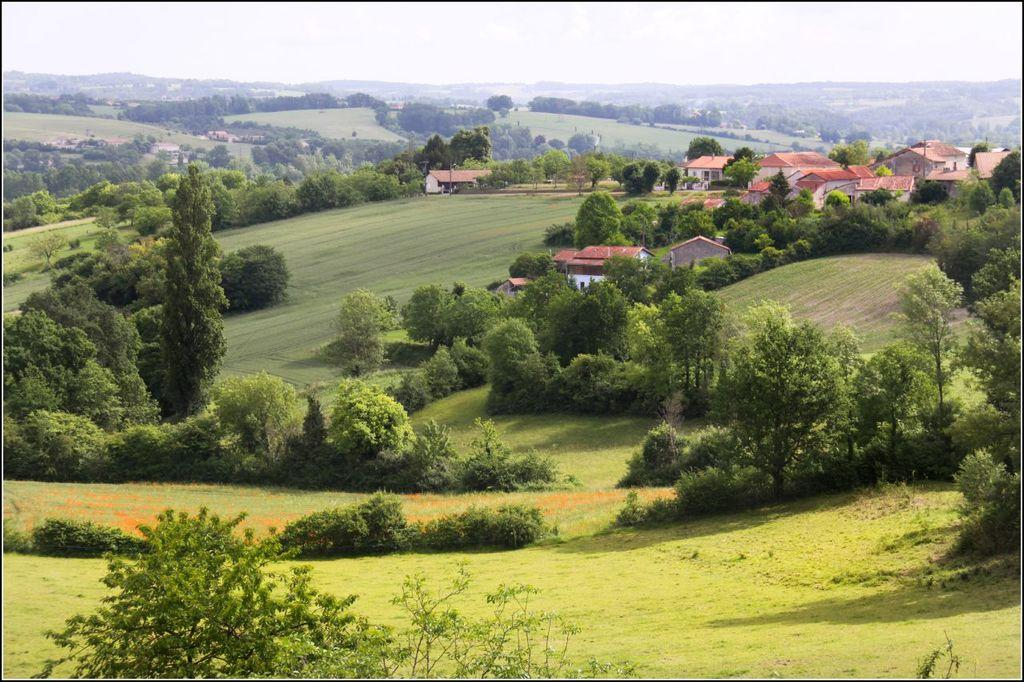What type of vegetation is present in the image? There are trees in the image. What is covering the ground in the image? There is grass on the ground in the image. What can be seen in the distance in the image? There are buildings in the background of the image. What is visible above the buildings in the image? The sky is visible in the background of the image. Can you see a cup of tea being enjoyed by an insect in the image? There is no cup of tea or insect present in the image. What type of stream can be seen flowing through the trees in the image? There is no stream visible in the image; it only features trees, grass, buildings, and the sky. 